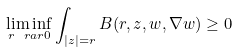Convert formula to latex. <formula><loc_0><loc_0><loc_500><loc_500>\liminf _ { r \ r a r 0 } \int _ { | z | = r } B ( r , z , w , \nabla w ) \geq 0</formula> 